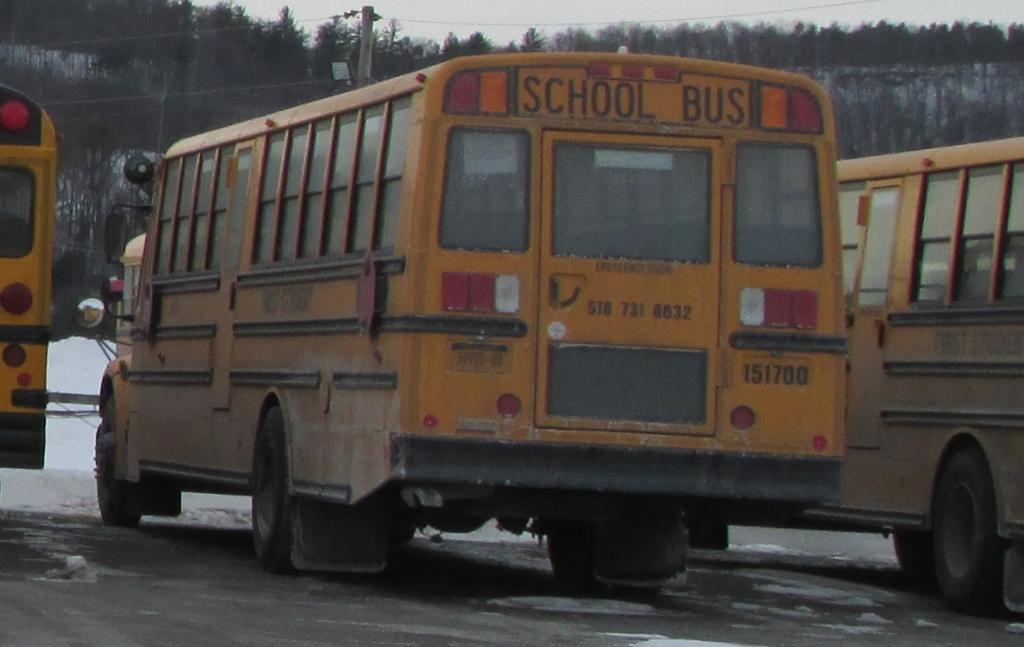In one or two sentences, can you explain what this image depicts? In this image we can see three school buses which are yellow in color are on road and in the background of the image there is some snow, electric pole and there are some trees. 